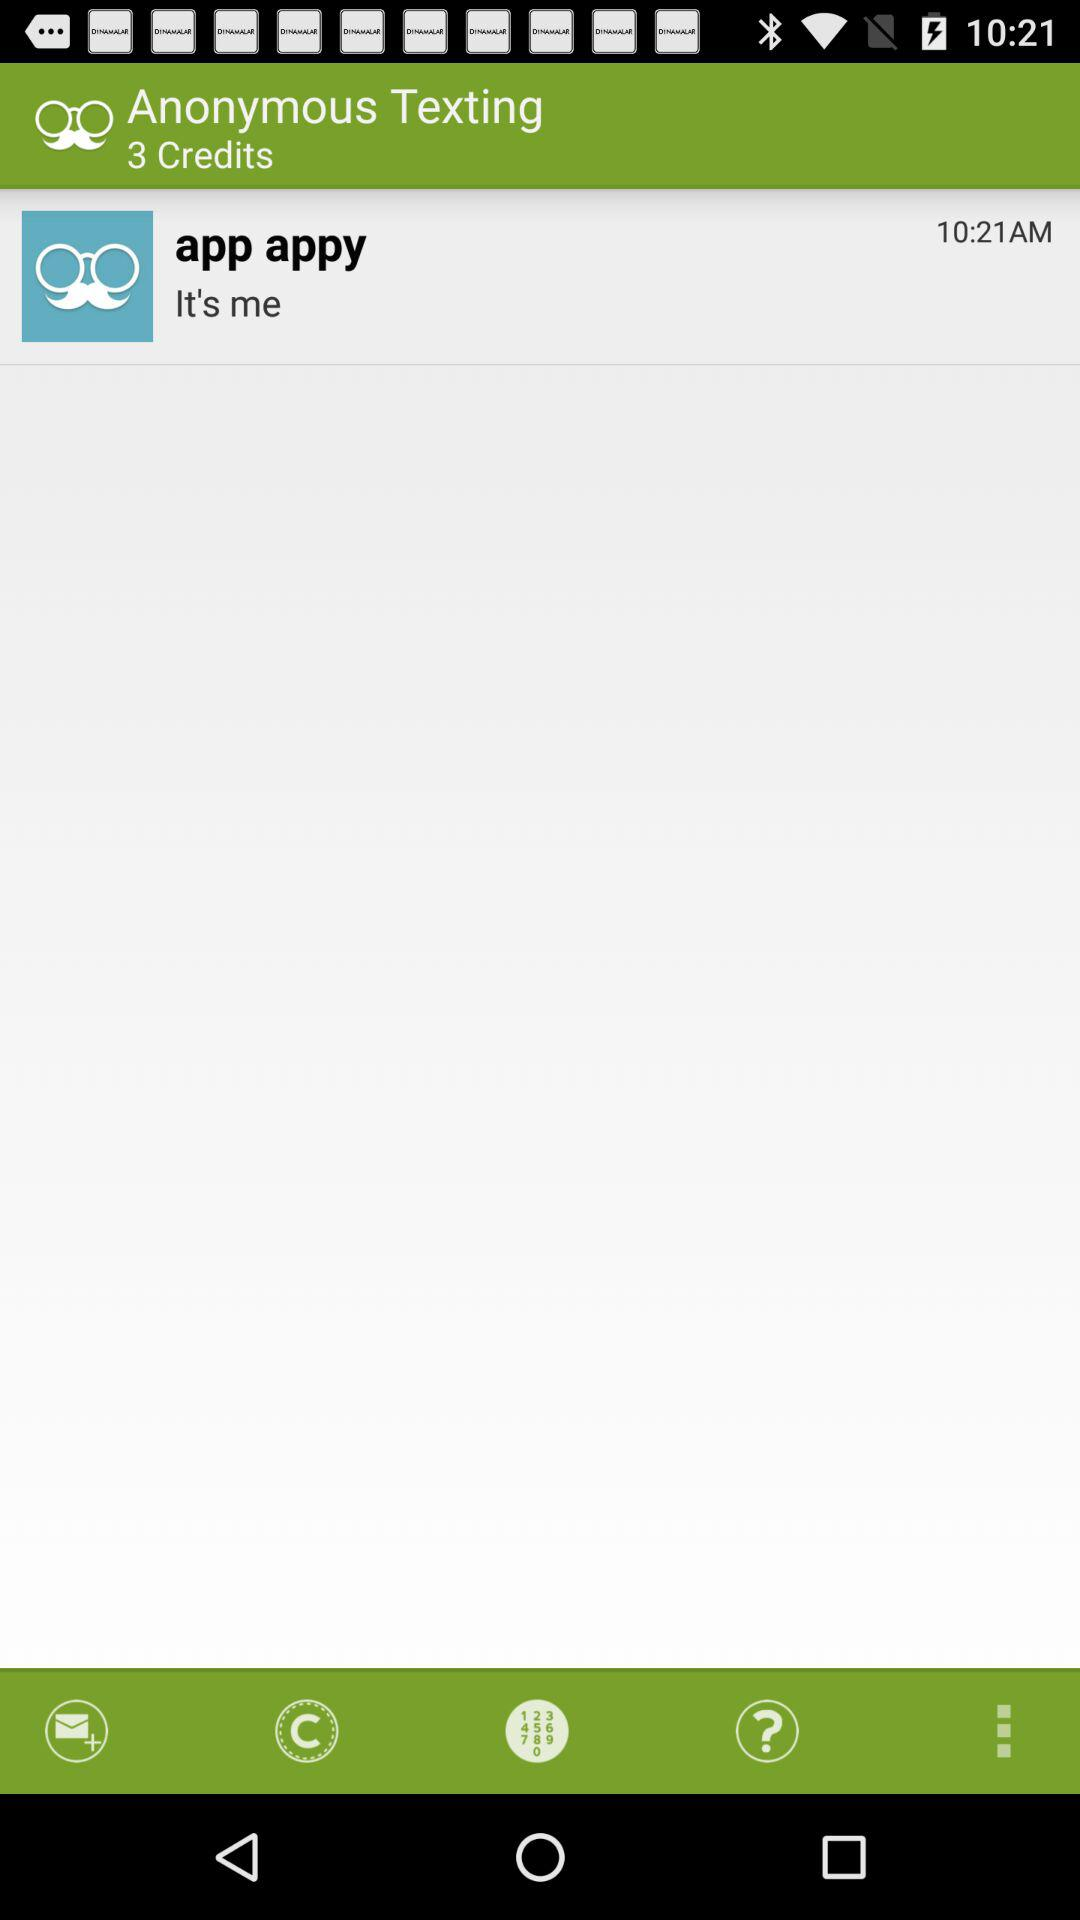How many credits are there? There are 3 credits. 